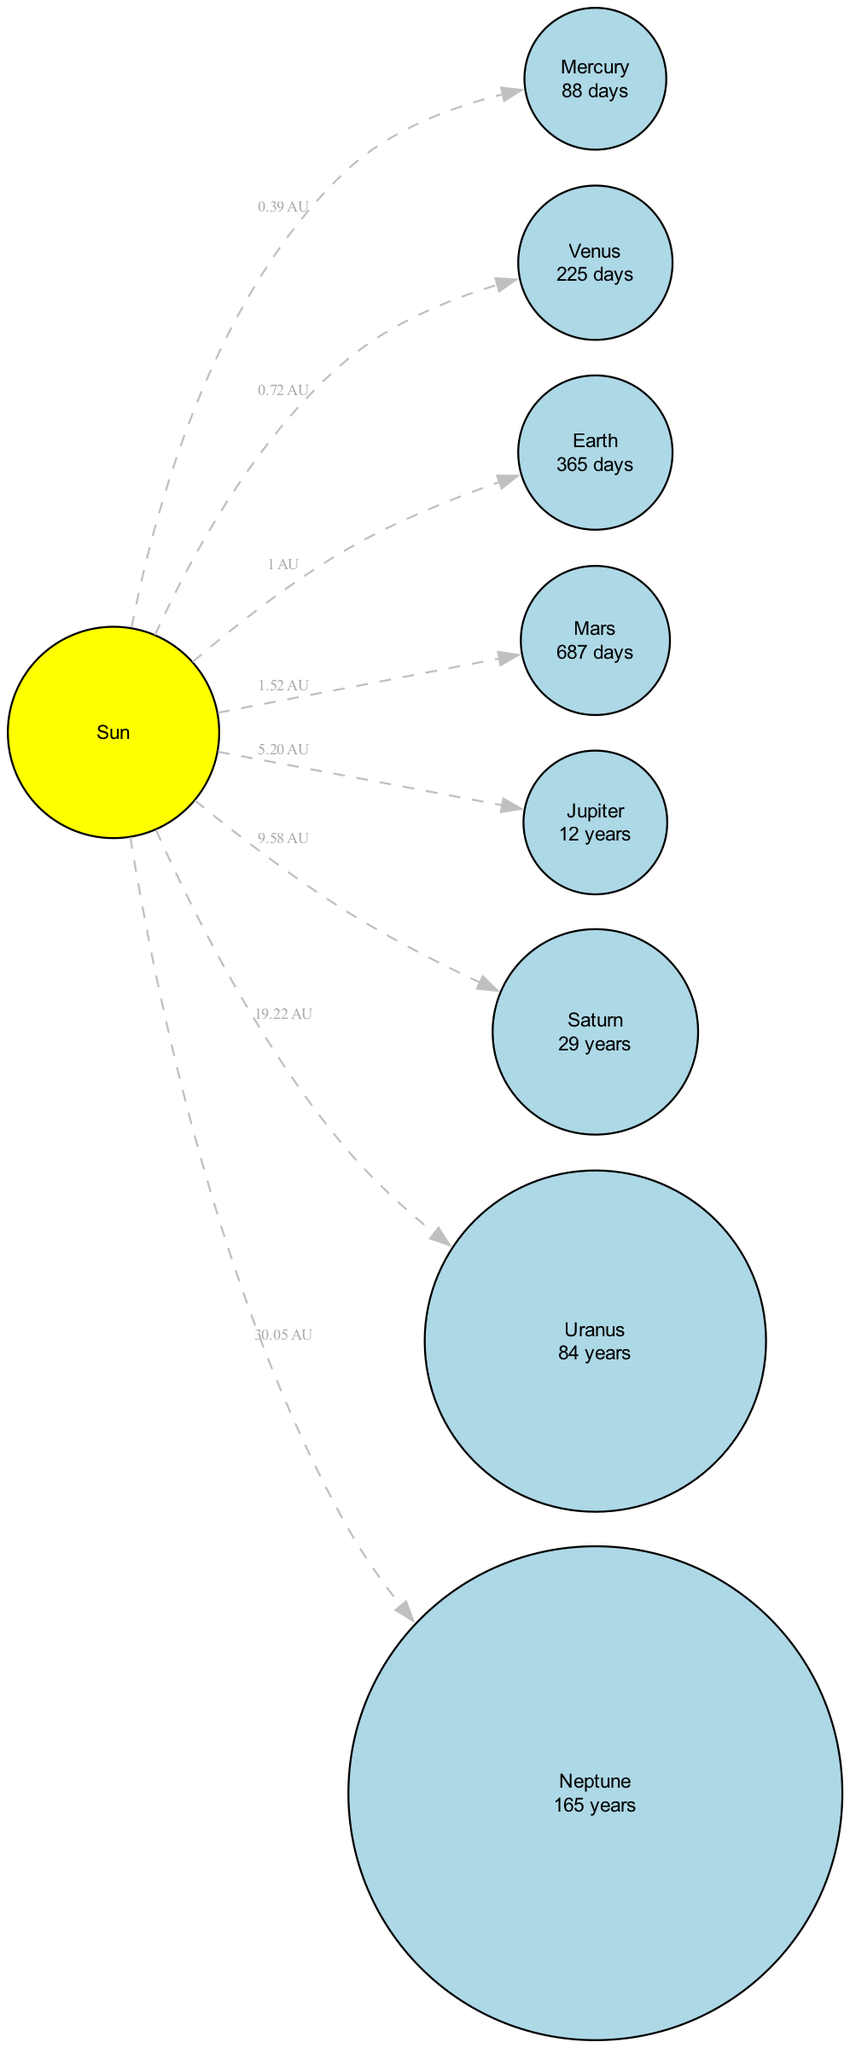What is the mean distance of Mars from the Sun? The diagram specifies that Mars has a mean distance from the Sun of 1.52 AU.
Answer: 1.52 AU Which planet has the longest orbital period? By comparing the orbital periods listed for all planets, Neptune has the longest orbital period at 165 years.
Answer: 165 years How many planets are shown in the diagram? The diagram lists eight celestial bodies, with seven of them classified as planets (Mercury, Venus, Earth, Mars, Jupiter, Saturn, Uranus, and Neptune), making the total count seven.
Answer: 7 What type is the Sun? The Sun is labeled as a "Star" in the details provided in the diagram.
Answer: Star Which planet is closest to the Sun? As per the diagram, Mercury is illustrated as the closest planet to the Sun, with a distance of 0.39 AU.
Answer: Mercury What is the orbital period of Jupiter? The diagram shows that Jupiter has an orbital period of 12 years.
Answer: 12 years How many AU is the distance from the Sun to Saturn? The distance from the Sun to Saturn is represented as 9.58 AU in the diagram.
Answer: 9.58 AU Which planet is furthest from the Sun? According to the diagram, Neptune is described as the furthest planet from the Sun at a distance of 30.05 AU.
Answer: Neptune What type of celestial body is Uranus? The diagram indicates that Uranus is categorized as a "Planet."
Answer: Planet 